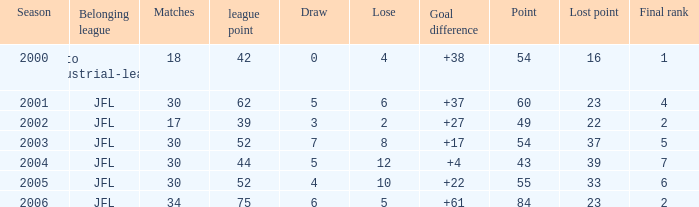Determine the mean defeat for lost points over 16, goal difference less than 37, and points not exceeding 4 None. 